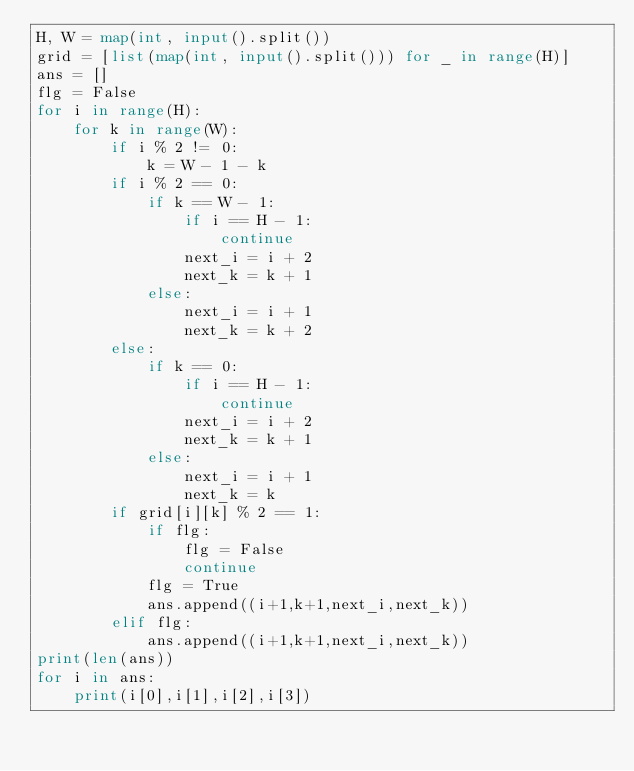Convert code to text. <code><loc_0><loc_0><loc_500><loc_500><_Python_>H, W = map(int, input().split())
grid = [list(map(int, input().split())) for _ in range(H)]
ans = []
flg = False
for i in range(H):
    for k in range(W):
        if i % 2 != 0:
            k = W - 1 - k
        if i % 2 == 0:
            if k == W - 1:
                if i == H - 1:
                    continue
                next_i = i + 2
                next_k = k + 1
            else:
                next_i = i + 1
                next_k = k + 2
        else:
            if k == 0:
                if i == H - 1:
                    continue
                next_i = i + 2
                next_k = k + 1
            else:
                next_i = i + 1
                next_k = k
        if grid[i][k] % 2 == 1:
            if flg:
                flg = False
                continue
            flg = True
            ans.append((i+1,k+1,next_i,next_k))
        elif flg:
            ans.append((i+1,k+1,next_i,next_k))
print(len(ans))
for i in ans:
    print(i[0],i[1],i[2],i[3])</code> 